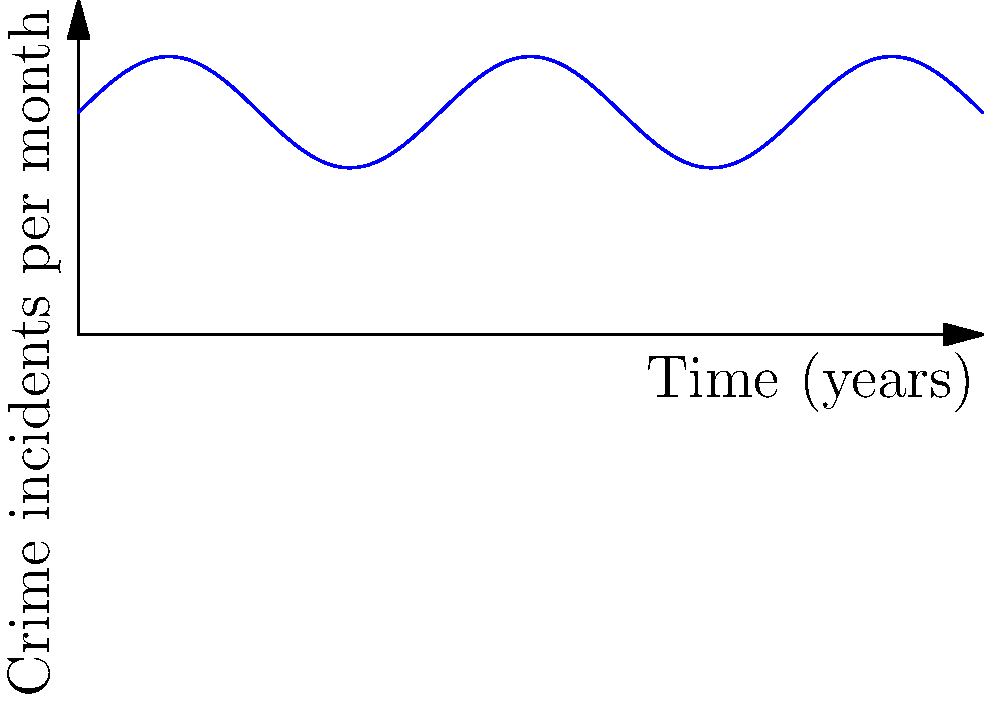The graph shows the number of crime incidents per month in your neighborhood over the past 10 years. At what point in time is the rate of change of crime incidents equal to zero? Explain your reasoning using calculus concepts. To solve this problem, we need to follow these steps:

1) The rate of change of crime incidents is represented by the derivative of the function.

2) The given function appears to be of the form:
   $$f(x) = 20 + 5\sin(\frac{\pi x}{2})$$

3) The derivative of this function is:
   $$f'(x) = 5 \cdot \frac{\pi}{2} \cos(\frac{\pi x}{2})$$

4) The rate of change is zero when $f'(x) = 0$:
   $$5 \cdot \frac{\pi}{2} \cos(\frac{\pi x}{2}) = 0$$

5) This occurs when $\cos(\frac{\pi x}{2}) = 0$

6) We know that cosine is zero when its argument is an odd multiple of $\frac{\pi}{2}$:
   $$\frac{\pi x}{2} = \frac{\pi}{2}, \frac{3\pi}{2}, \frac{5\pi}{2}, ...$$

7) Solving for x:
   $$x = 1, 3, 5, ...$$

8) Given that the graph only shows 10 years, the points where the rate of change is zero are at 1, 3, 5, 7, and 9 years.
Answer: 1, 3, 5, 7, and 9 years 